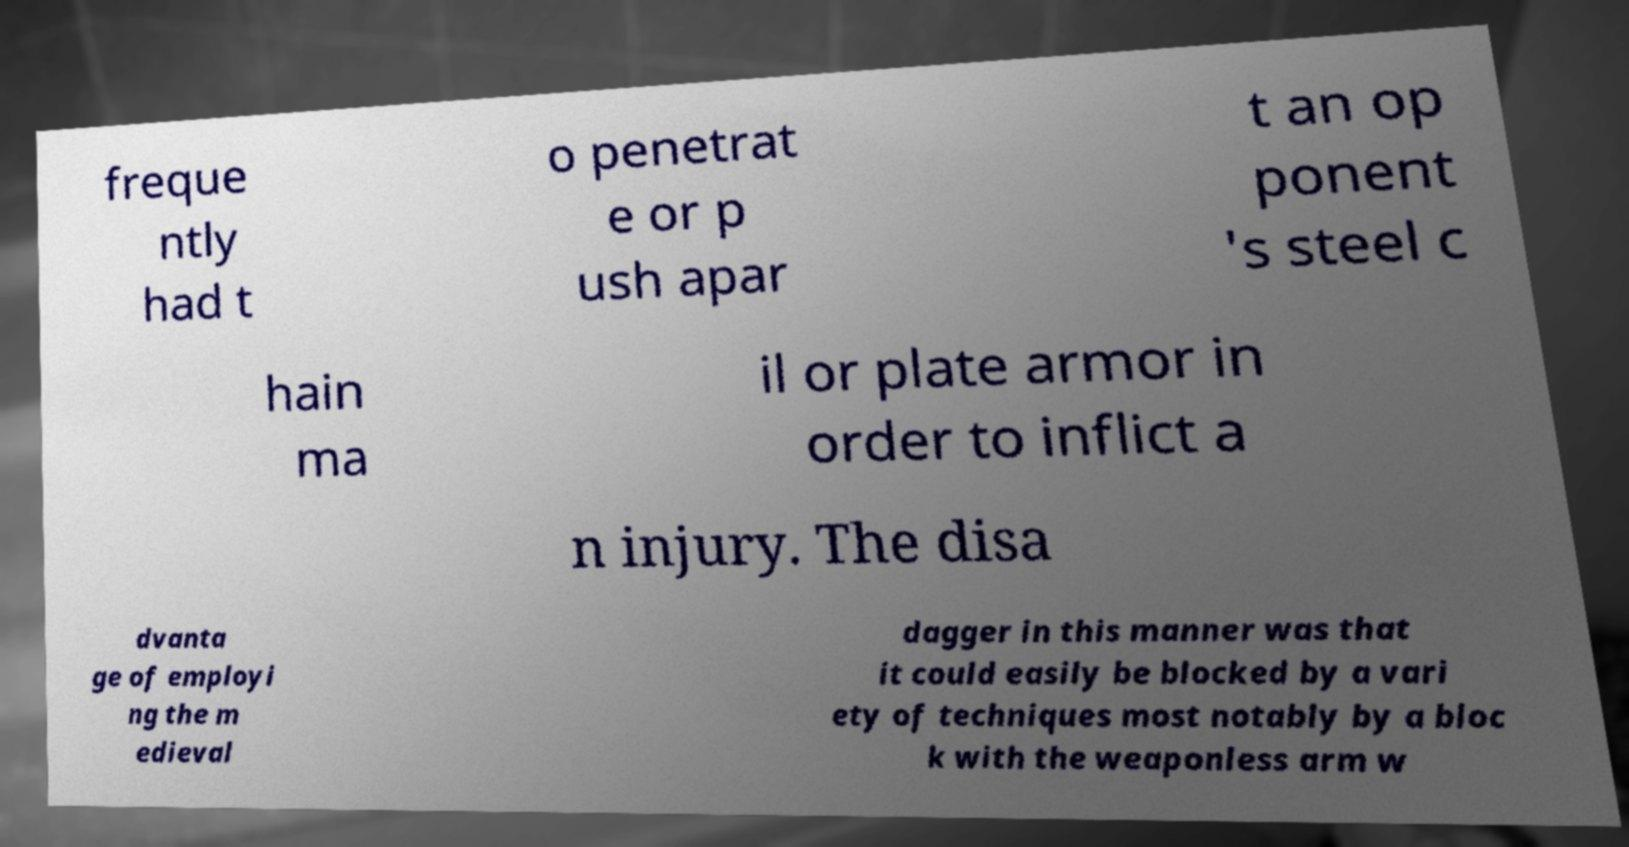Can you accurately transcribe the text from the provided image for me? freque ntly had t o penetrat e or p ush apar t an op ponent 's steel c hain ma il or plate armor in order to inflict a n injury. The disa dvanta ge of employi ng the m edieval dagger in this manner was that it could easily be blocked by a vari ety of techniques most notably by a bloc k with the weaponless arm w 